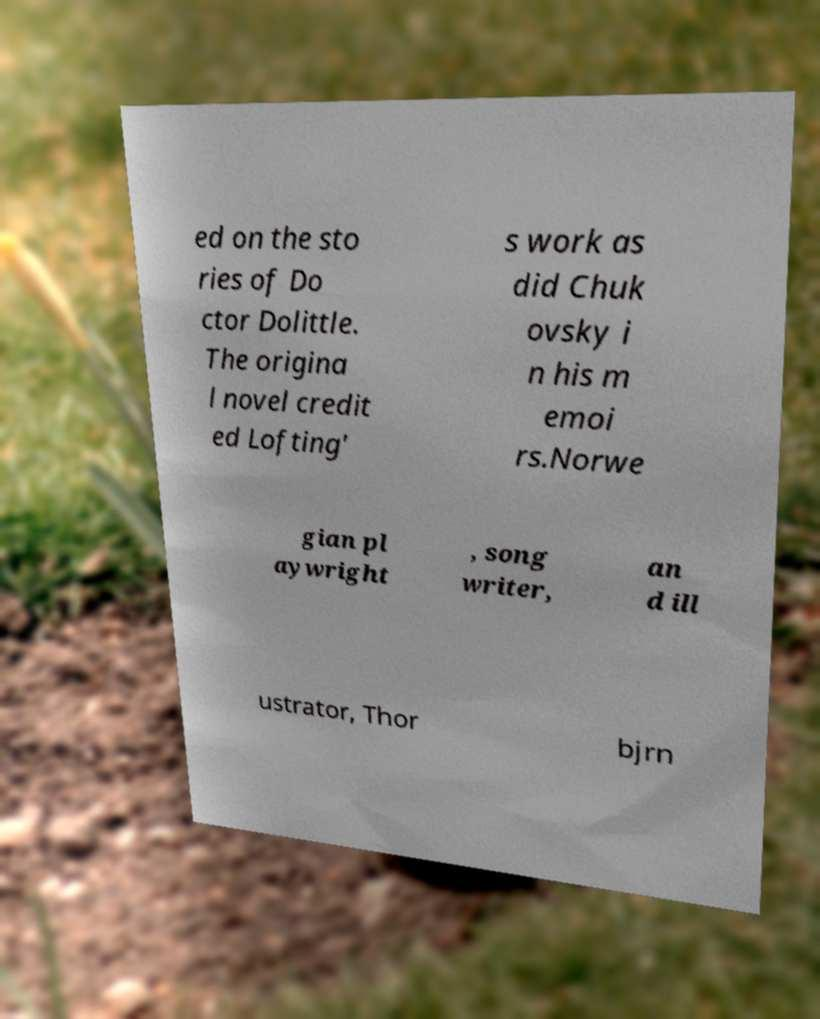I need the written content from this picture converted into text. Can you do that? ed on the sto ries of Do ctor Dolittle. The origina l novel credit ed Lofting' s work as did Chuk ovsky i n his m emoi rs.Norwe gian pl aywright , song writer, an d ill ustrator, Thor bjrn 